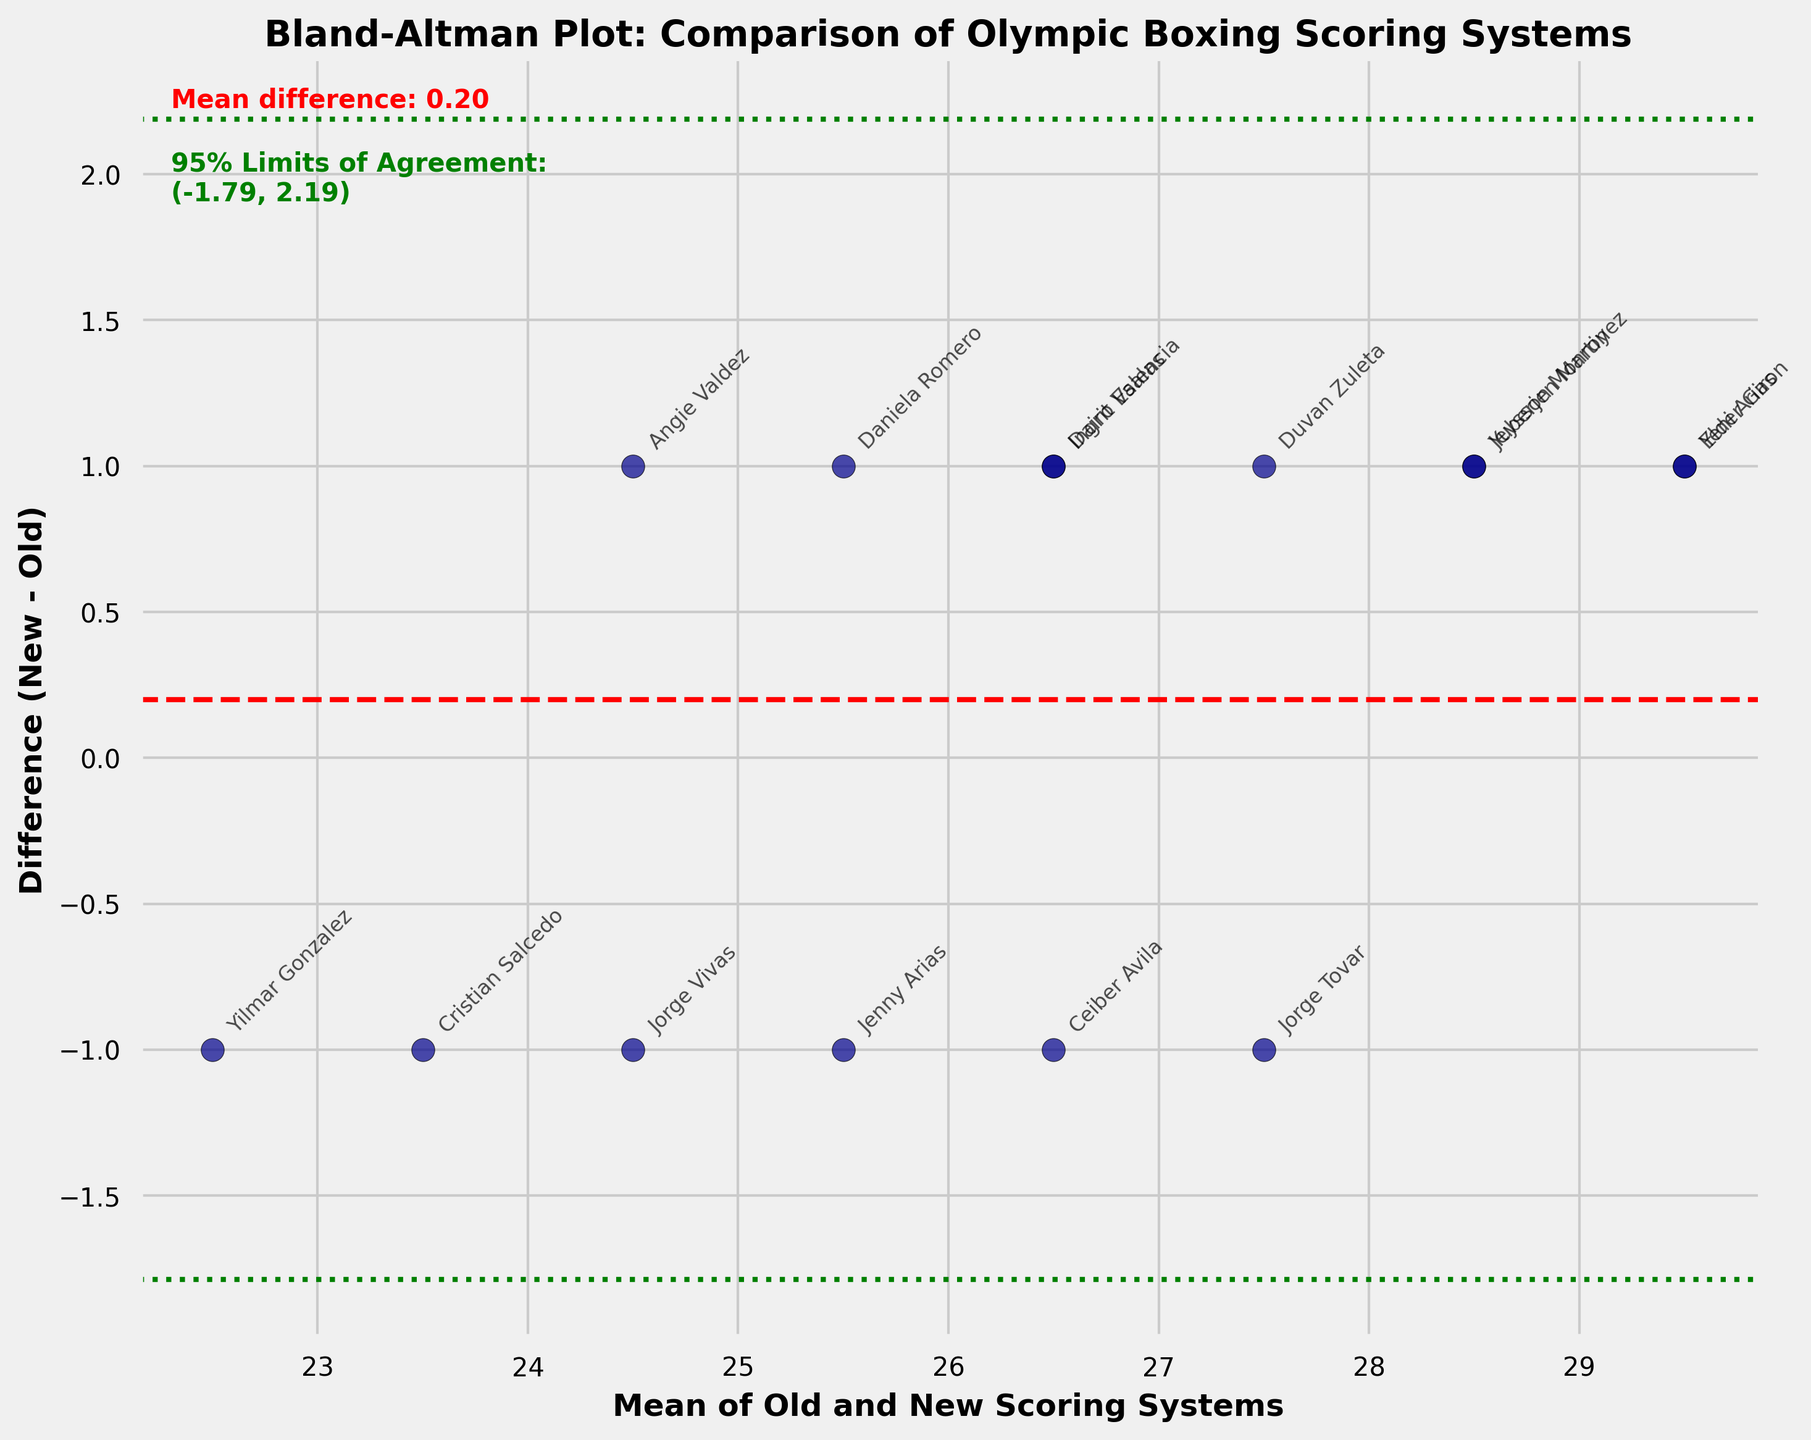What's the mean difference between the new and old scoring systems? The mean difference is typically represented by a red dashed horizontal line. From the plot, the mean difference (also shown in the text within the plot) is calculated as the average of the differences between the new and old scores. This value is approximately 0.67.
Answer: 0.67 What does the green dotted lines represent? The green dotted lines represent the 95% limits of agreement. These are calculated as mean difference ± 1.96 * standard deviation of the differences. The lines indicate the range in which 95% of the differences between the two scoring systems are expected to fall.
Answer: 95% limits of agreement How do the scores of Yuberjen Martinez compare between the old and new scoring systems? To compare the scores, find the point labeled "Yuberjen Martinez" on the plot. The x-axis value represents the mean score and the y-axis value shows the difference between new and old scores. Yuberjen Martinez has a mean score of 28.5 and a difference of 1 (29 from New System and 28 from Old System). This suggests the new scoring system gives him one point higher.
Answer: New System is 1 point higher Which boxer has the largest positive difference between the new and old scoring systems? To find the largest positive difference, look for the point furthest above the horizontal axis. Upon examining the labels and points, Yeni Arias and Elder Giron have the highest positive differences, both around 1 (30 - 29).
Answer: Yeni Arias and Elder Giron Are there any boxers for whom the old scoring system gave a higher score than the new scoring system? Check below the horizontal axis to find the points where the differences are negative. The plot shows that Ceiber Avila and Jenny Arias have negative differences, meaning their old scores are higher than their new scores.
Answer: Ceiber Avila and Jenny Arias What do the points on the plot represent? Each point on the plot represents a boxer and is positioned based on their mean score (x-axis) and the difference between their new and old scores (y-axis). The labeling next to the points helps to identify each boxer.
Answer: Each point represents a boxer How wide are the 95% limits of agreement? The width of the limits of agreement is the range between the upper and lower green dotted lines. The upper limit is approximately 1.21, and the lower limit is approximately -0.13. So, the width is 1.21 - (-0.13) = 1.34.
Answer: 1.34 What is the average mean score for the boxers in the plot? The average mean score is found by calculating the mean of the x-axis values. Sum up the mean scores of all boxers and divide by the total number of boxers (15). ((28.5 + 26.5 + 26.5 + 24.5 + 29.5 + 23.5 + 26.5 + 28.5 + 25.5 + 27.5 + 22.5 + 25.5 + 29.5 + 24.5 + 27.5)/15).
Answer: 26.53 